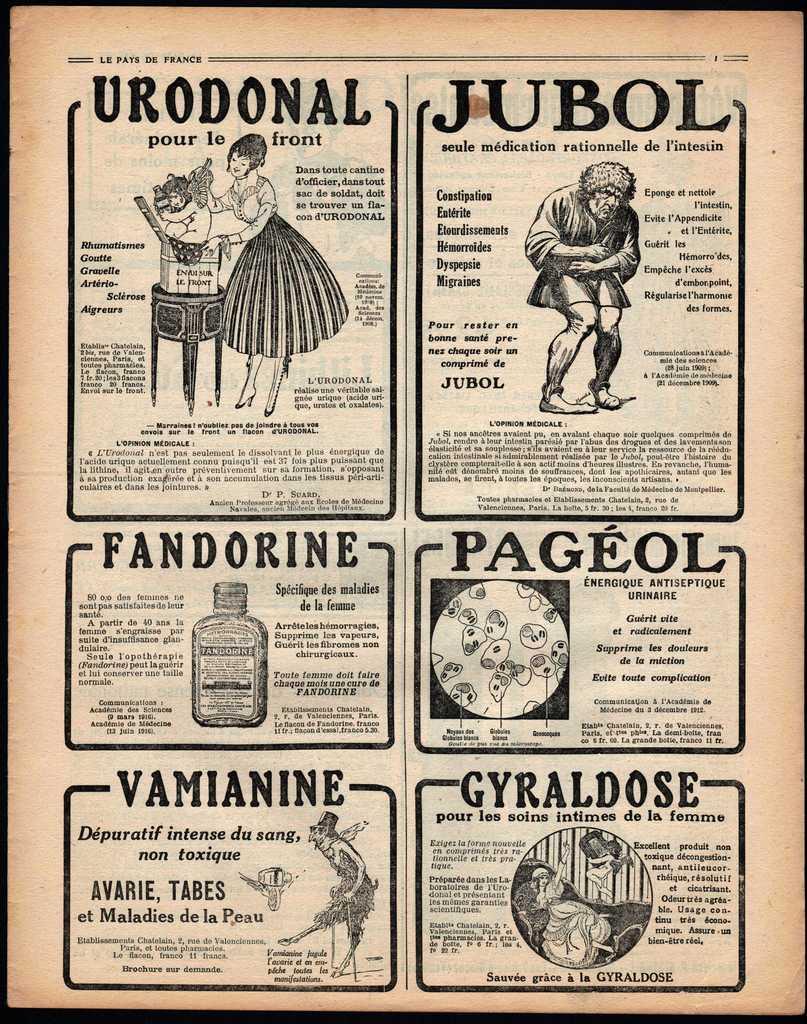In one or two sentences, can you explain what this image depicts? As we can see in the image there is a paper, On paper there is a man, woman, table, box, bottle and something written. 